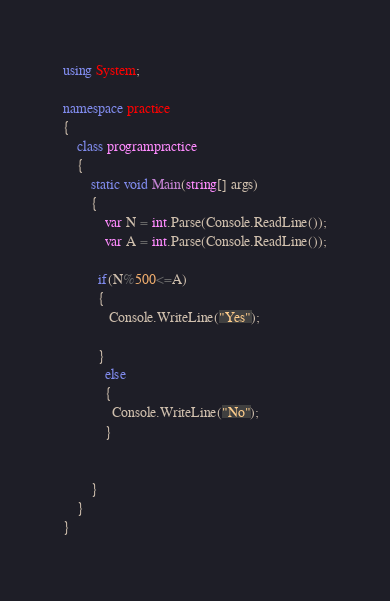<code> <loc_0><loc_0><loc_500><loc_500><_C#_>using System;
 
namespace practice
{
    class programpractice
    {
        static void Main(string[] args)
        {
            var N = int.Parse(Console.ReadLine());
            var A = int.Parse(Console.ReadLine());
          
          if(N%500<=A)
          {
             Console.WriteLine("Yes");
 
          }
            else
            {
              Console.WriteLine("No");
            }
 
           
        }
    }
}</code> 